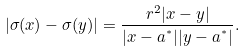<formula> <loc_0><loc_0><loc_500><loc_500>| \sigma ( x ) - \sigma ( y ) | = \frac { r ^ { 2 } | x - y | } { | x - a ^ { ^ { * } } | | y - a ^ { ^ { * } } | } .</formula> 